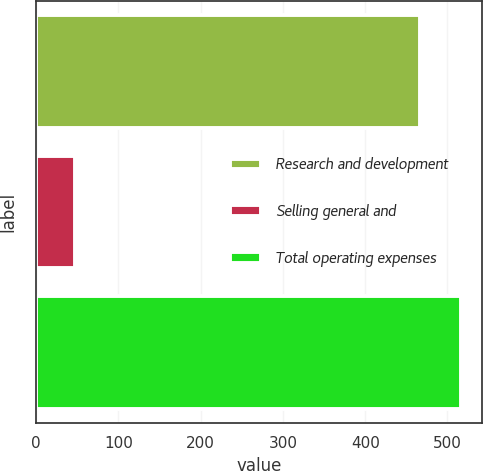<chart> <loc_0><loc_0><loc_500><loc_500><bar_chart><fcel>Research and development<fcel>Selling general and<fcel>Total operating expenses<nl><fcel>466.9<fcel>47.6<fcel>516.6<nl></chart> 